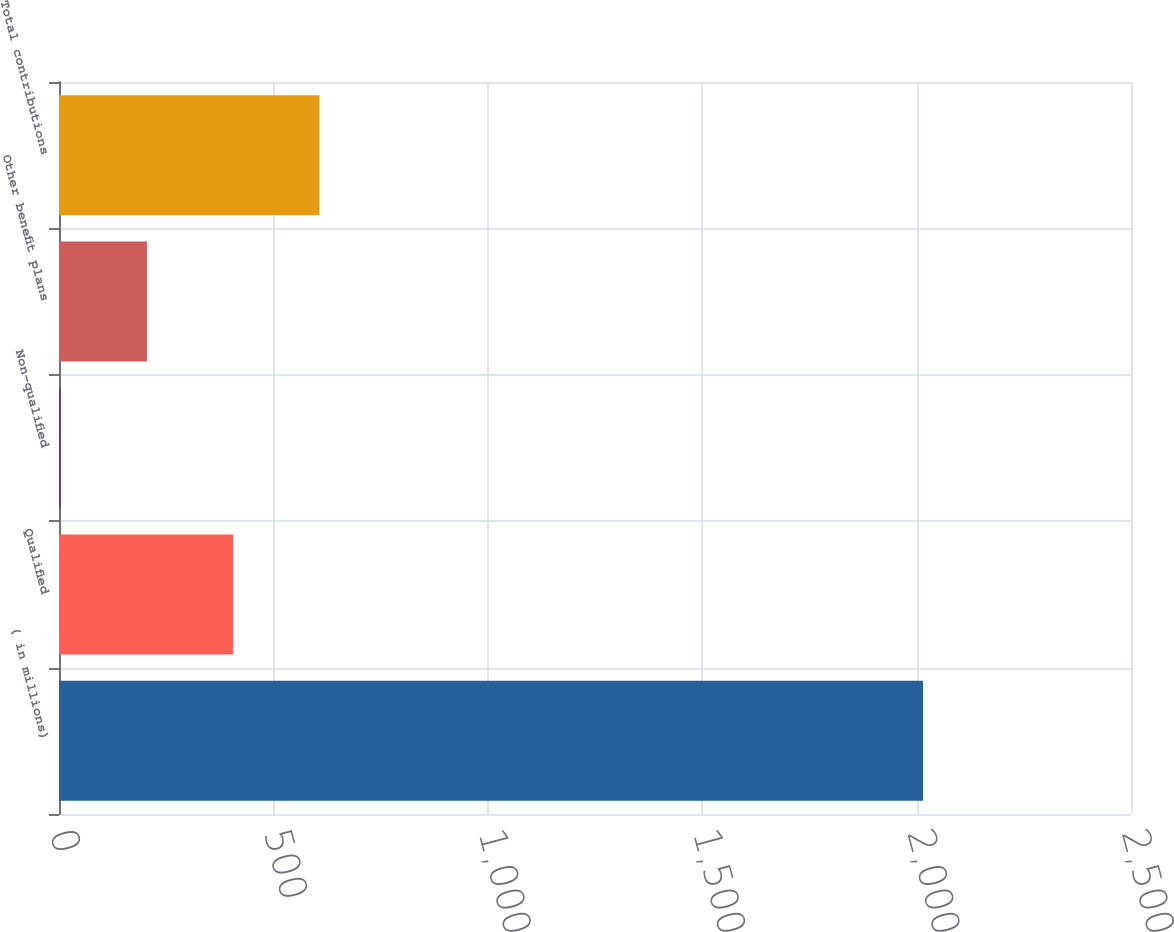<chart> <loc_0><loc_0><loc_500><loc_500><bar_chart><fcel>( in millions)<fcel>Qualified<fcel>Non-qualified<fcel>Other benefit plans<fcel>Total contributions<nl><fcel>2015<fcel>406.2<fcel>4<fcel>205.1<fcel>607.3<nl></chart> 